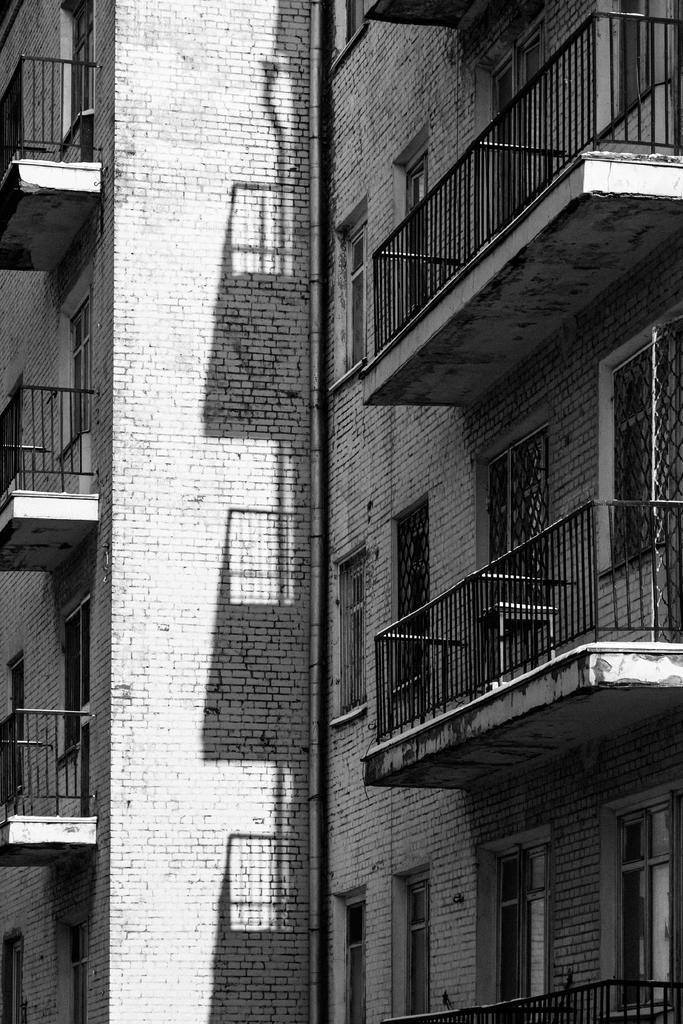What type of architectural feature is present in the image? There are many windows and balconies in the image. What material is the building made of? The building in the image is made of bricks. How many ladybugs can be seen crawling on the bricks in the image? There are no ladybugs present in the image; it only features windows, balconies, and a brick building. 